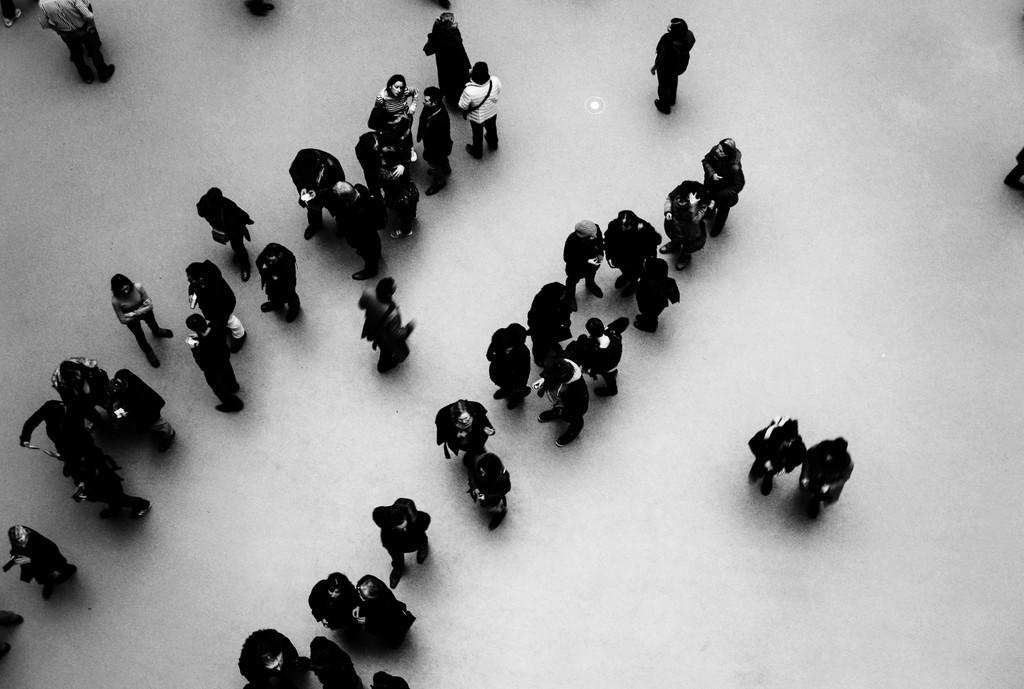What is happening with the people in the image? The people are standing on the floor in the image. What is the color scheme of the image? The image is black and white. Can you describe the gender of the people in the image? There are men and women in the image. What type of wave can be seen crashing on the shore in the image? There is no wave or shore present in the image; it features people standing on the floor. Can you tell me how many firemen are visible in the image? There are no firemen present in the image; it features both men and women. 